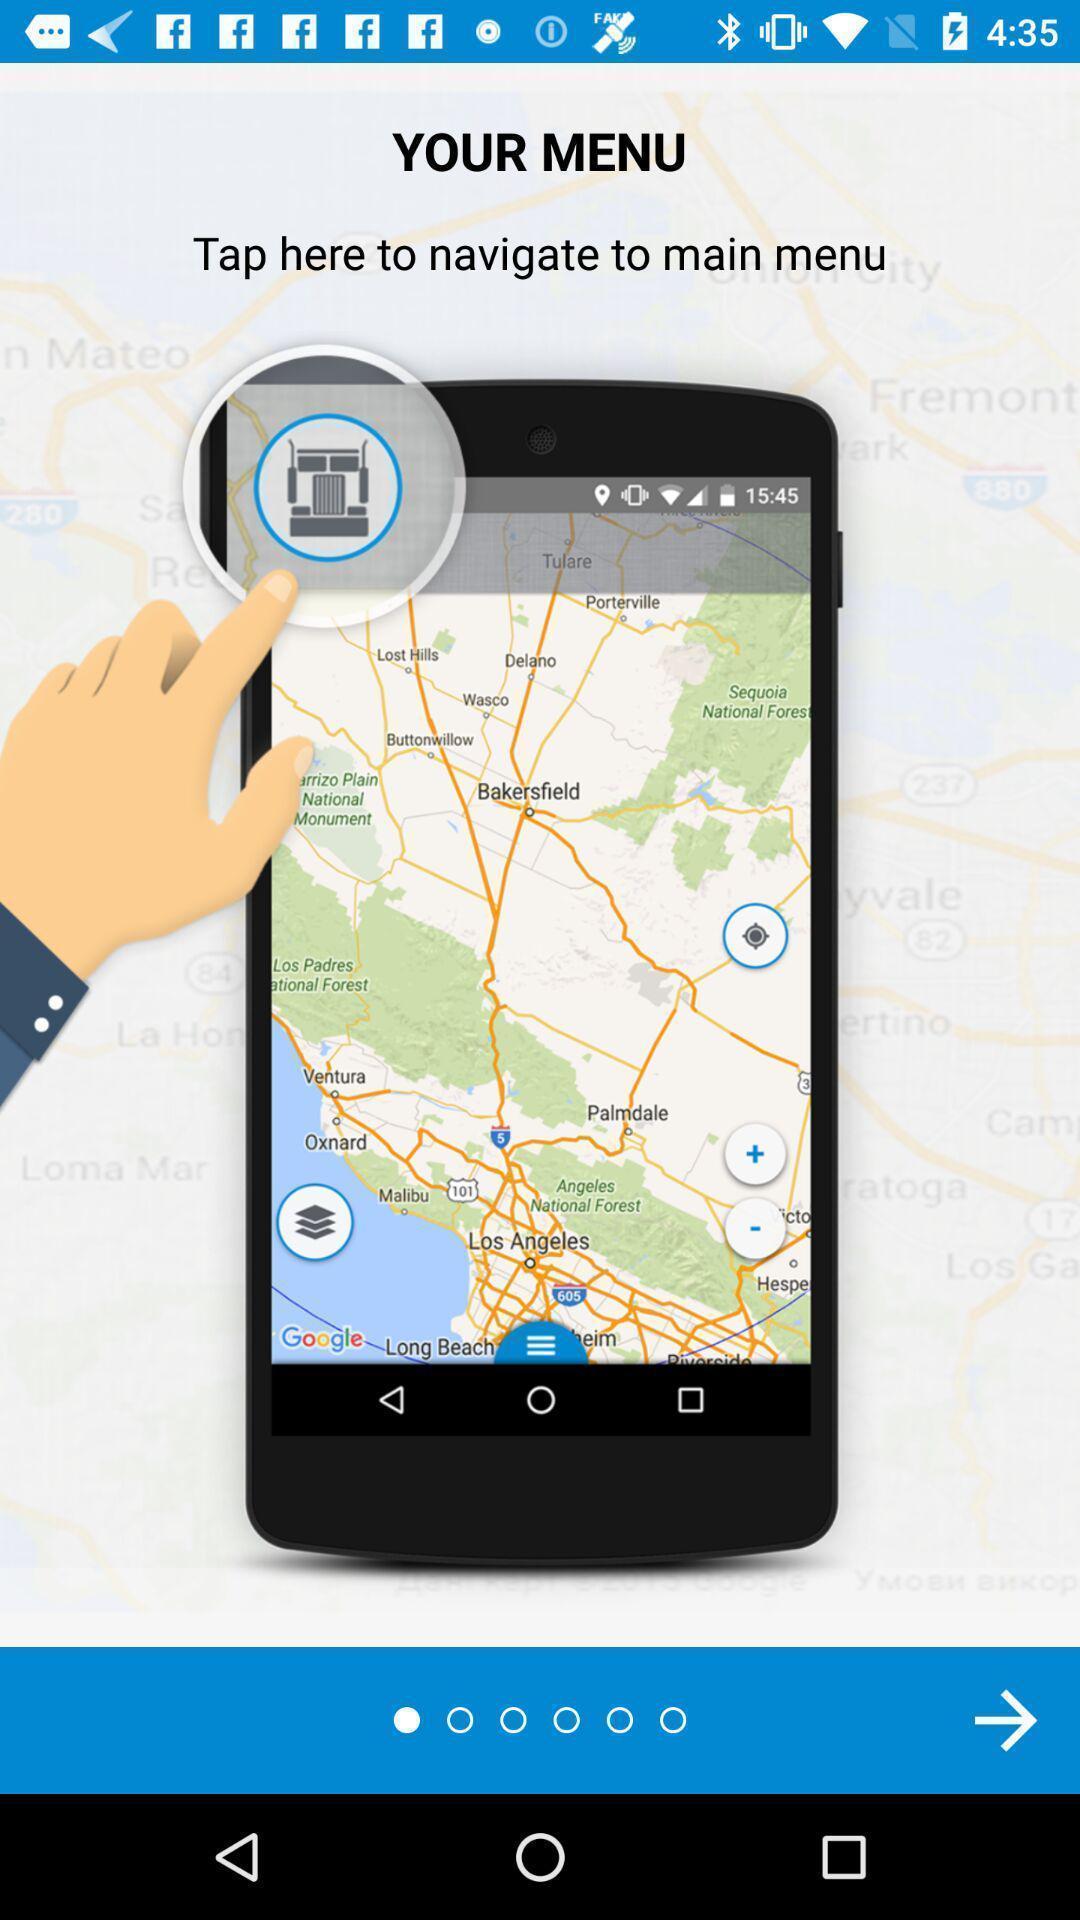Provide a description of this screenshot. Welcome page of an navigation app. 